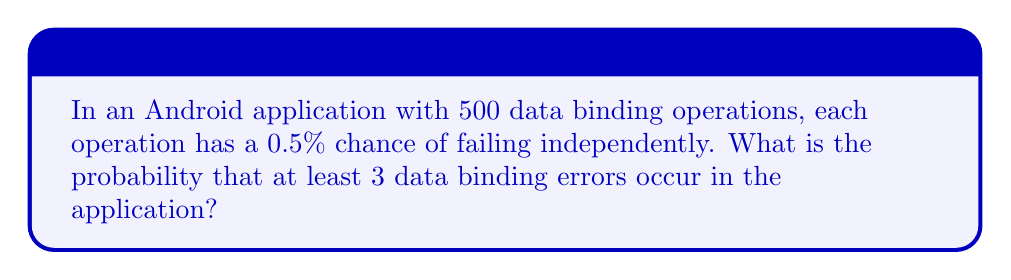Could you help me with this problem? Let's approach this step-by-step:

1) This is a binomial probability problem. We need to find P(X ≥ 3), where X is the number of errors.

2) The parameters for our binomial distribution are:
   n = 500 (number of trials)
   p = 0.005 (probability of failure for each trial)
   q = 1 - p = 0.995 (probability of success for each trial)

3) Instead of calculating P(X ≥ 3) directly, it's easier to calculate 1 - P(X < 3):

   P(X ≥ 3) = 1 - P(X < 3) = 1 - [P(X = 0) + P(X = 1) + P(X = 2)]

4) We can calculate each probability using the binomial probability formula:

   $$P(X = k) = \binom{n}{k} p^k q^{n-k}$$

5) Calculating each term:

   P(X = 0) = $\binom{500}{0} (0.005)^0 (0.995)^{500} = 0.0821$

   P(X = 1) = $\binom{500}{1} (0.005)^1 (0.995)^{499} = 0.2052$

   P(X = 2) = $\binom{500}{2} (0.005)^2 (0.995)^{498} = 0.2560$

6) Sum these probabilities:

   P(X < 3) = 0.0821 + 0.2052 + 0.2560 = 0.5433

7) Therefore, the probability of at least 3 errors is:

   P(X ≥ 3) = 1 - 0.5433 = 0.4567
Answer: 0.4567 